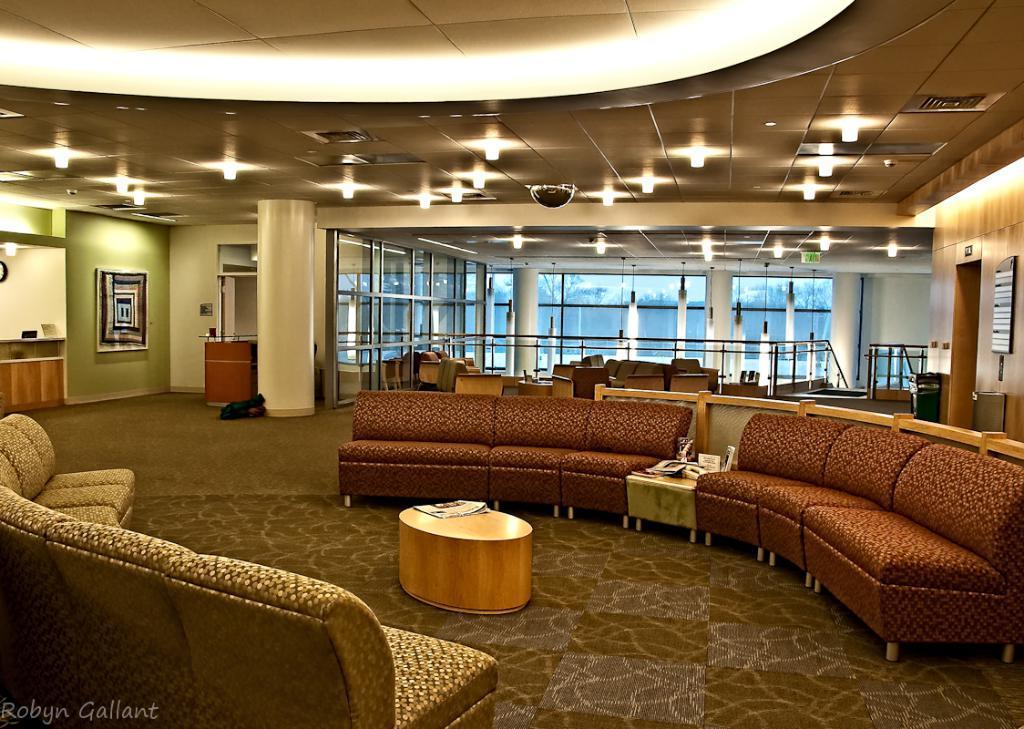In one or two sentences, can you explain what this image depicts? In this image we can see sofa set on the floor, and in front here is the table. Here at back are the chairs, and here is the wall, and at above here are the lights. 